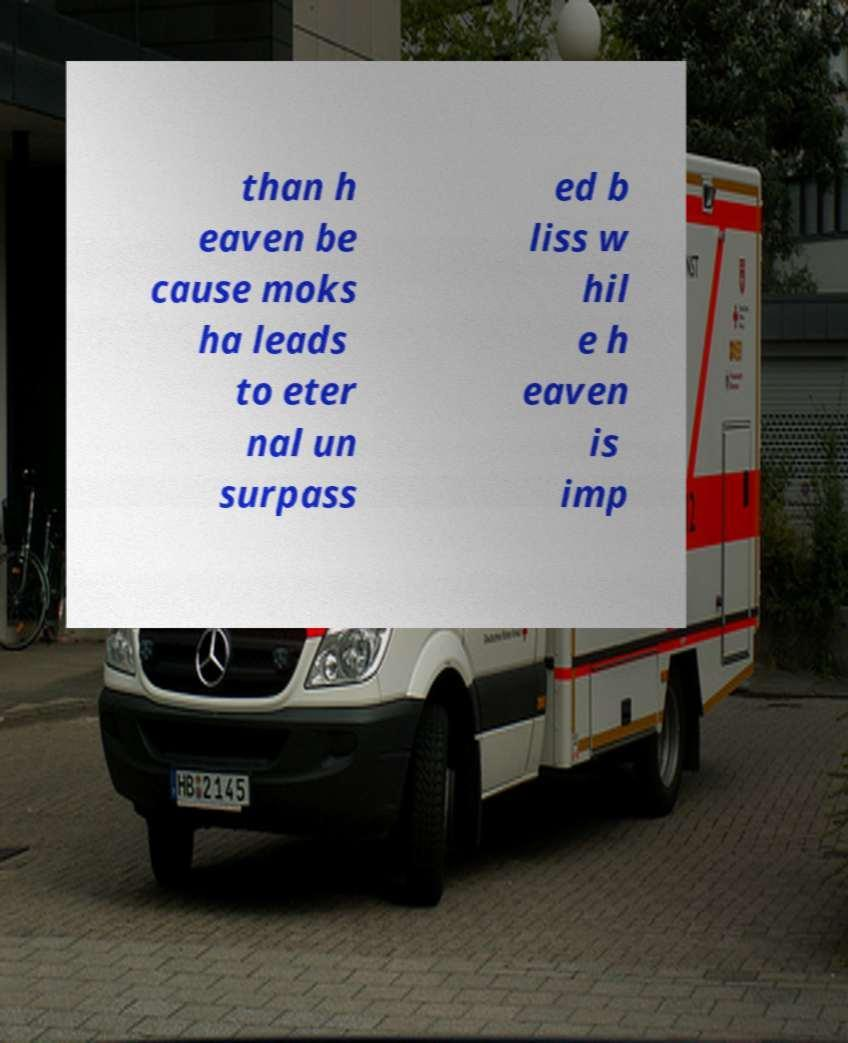For documentation purposes, I need the text within this image transcribed. Could you provide that? than h eaven be cause moks ha leads to eter nal un surpass ed b liss w hil e h eaven is imp 